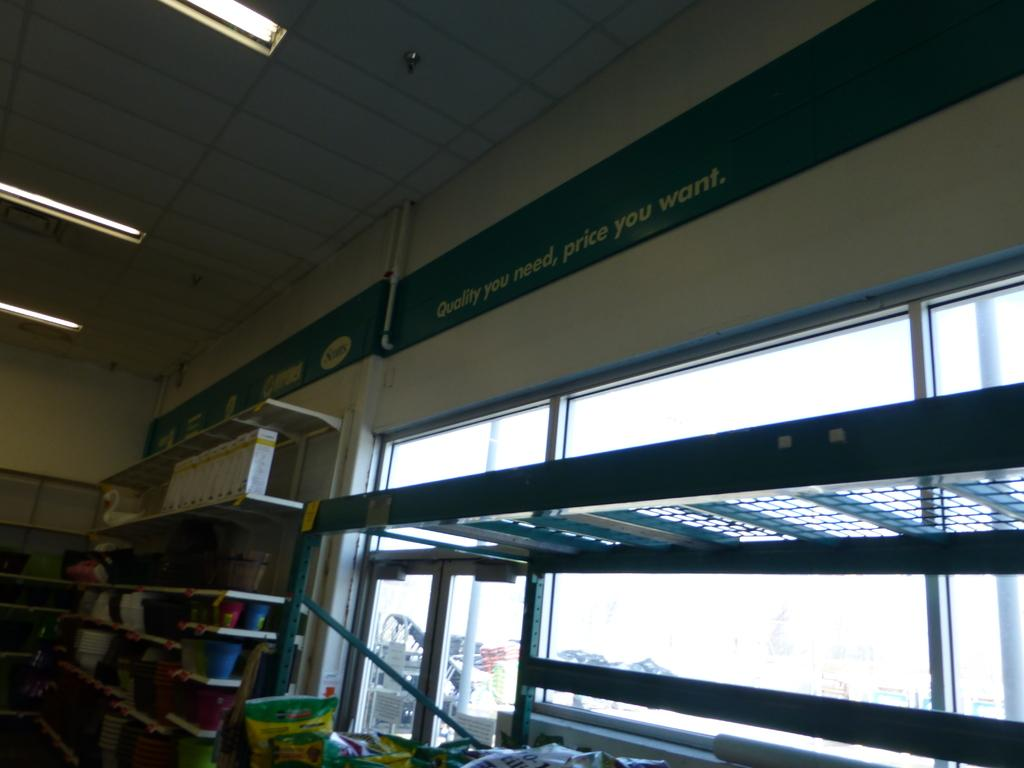<image>
Create a compact narrative representing the image presented. A rather empty store with a banner saying quality you need, price you want. 